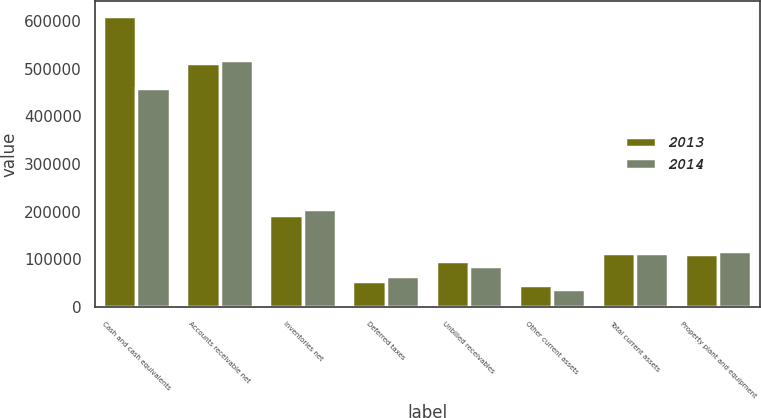Convert chart. <chart><loc_0><loc_0><loc_500><loc_500><stacked_bar_chart><ecel><fcel>Cash and cash equivalents<fcel>Accounts receivable net<fcel>Inventories net<fcel>Deferred taxes<fcel>Unbilled receivables<fcel>Other current assets<fcel>Total current assets<fcel>Property plant and equipment<nl><fcel>2013<fcel>610430<fcel>511538<fcel>193766<fcel>54199<fcel>96409<fcel>45763<fcel>114093<fcel>110876<nl><fcel>2014<fcel>459720<fcel>519075<fcel>204923<fcel>64464<fcel>86945<fcel>38210<fcel>114093<fcel>117310<nl></chart> 